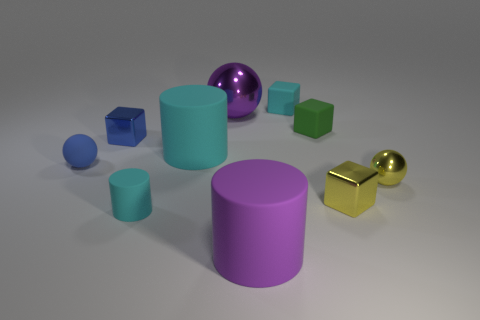Subtract all green spheres. How many cyan cylinders are left? 2 Subtract all large matte cylinders. How many cylinders are left? 1 Subtract all blue cubes. How many cubes are left? 3 Subtract 2 spheres. How many spheres are left? 1 Subtract all balls. How many objects are left? 7 Subtract all red cylinders. Subtract all green cubes. How many cylinders are left? 3 Subtract all large yellow spheres. Subtract all large purple cylinders. How many objects are left? 9 Add 2 cyan matte cylinders. How many cyan matte cylinders are left? 4 Add 7 large matte cylinders. How many large matte cylinders exist? 9 Subtract 0 cyan spheres. How many objects are left? 10 